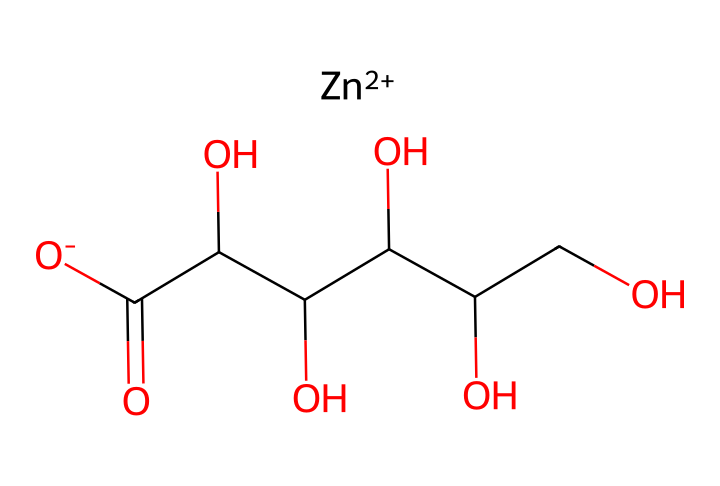What is the chemical name of this structure? The SMILES representation describes zinc gluconate, which is recognized by its composition of zinc and gluconic acid. This name is derived from the component parts of the chemical structure.
Answer: zinc gluconate How many carbon atoms are present in this molecule? By analyzing the SMILES representation, we can count the number of carbon (C) atoms that appear in the structure. There are 6 carbon atoms in the gluconic acid part.
Answer: 6 What is the oxidation state of zinc in this compound? In the SMILES representation, the zinc is shown as [Zn++], indicating that it has a +2 oxidation state. This infers that zinc is doubly charged and commonly found in this state in biological and chemical systems.
Answer: +2 How many hydroxyl groups are there in zinc gluconate? The structure includes multiple -OH (hydroxyl) groups. By inspecting the osmotic structure of gluconate in the SMILES, it reveals 5 hydroxyl groups present in this molecule.
Answer: 5 What role does zinc play in this electrolyte? Zinc is an essential trace element in the body that plays a significant role in various physiological functions, including enzyme activity and immune function. Thus, in the context of hydration tablets, it helps maintain electrolyte balance and supports performance.
Answer: essential trace element Is zinc gluconate soluble in water? Based on known properties of zinc gluconate and the presence of polar functional groups (like hydroxyls), the chemical is expected to be soluble in water, which facilitates its use in hydration solutions.
Answer: soluble 